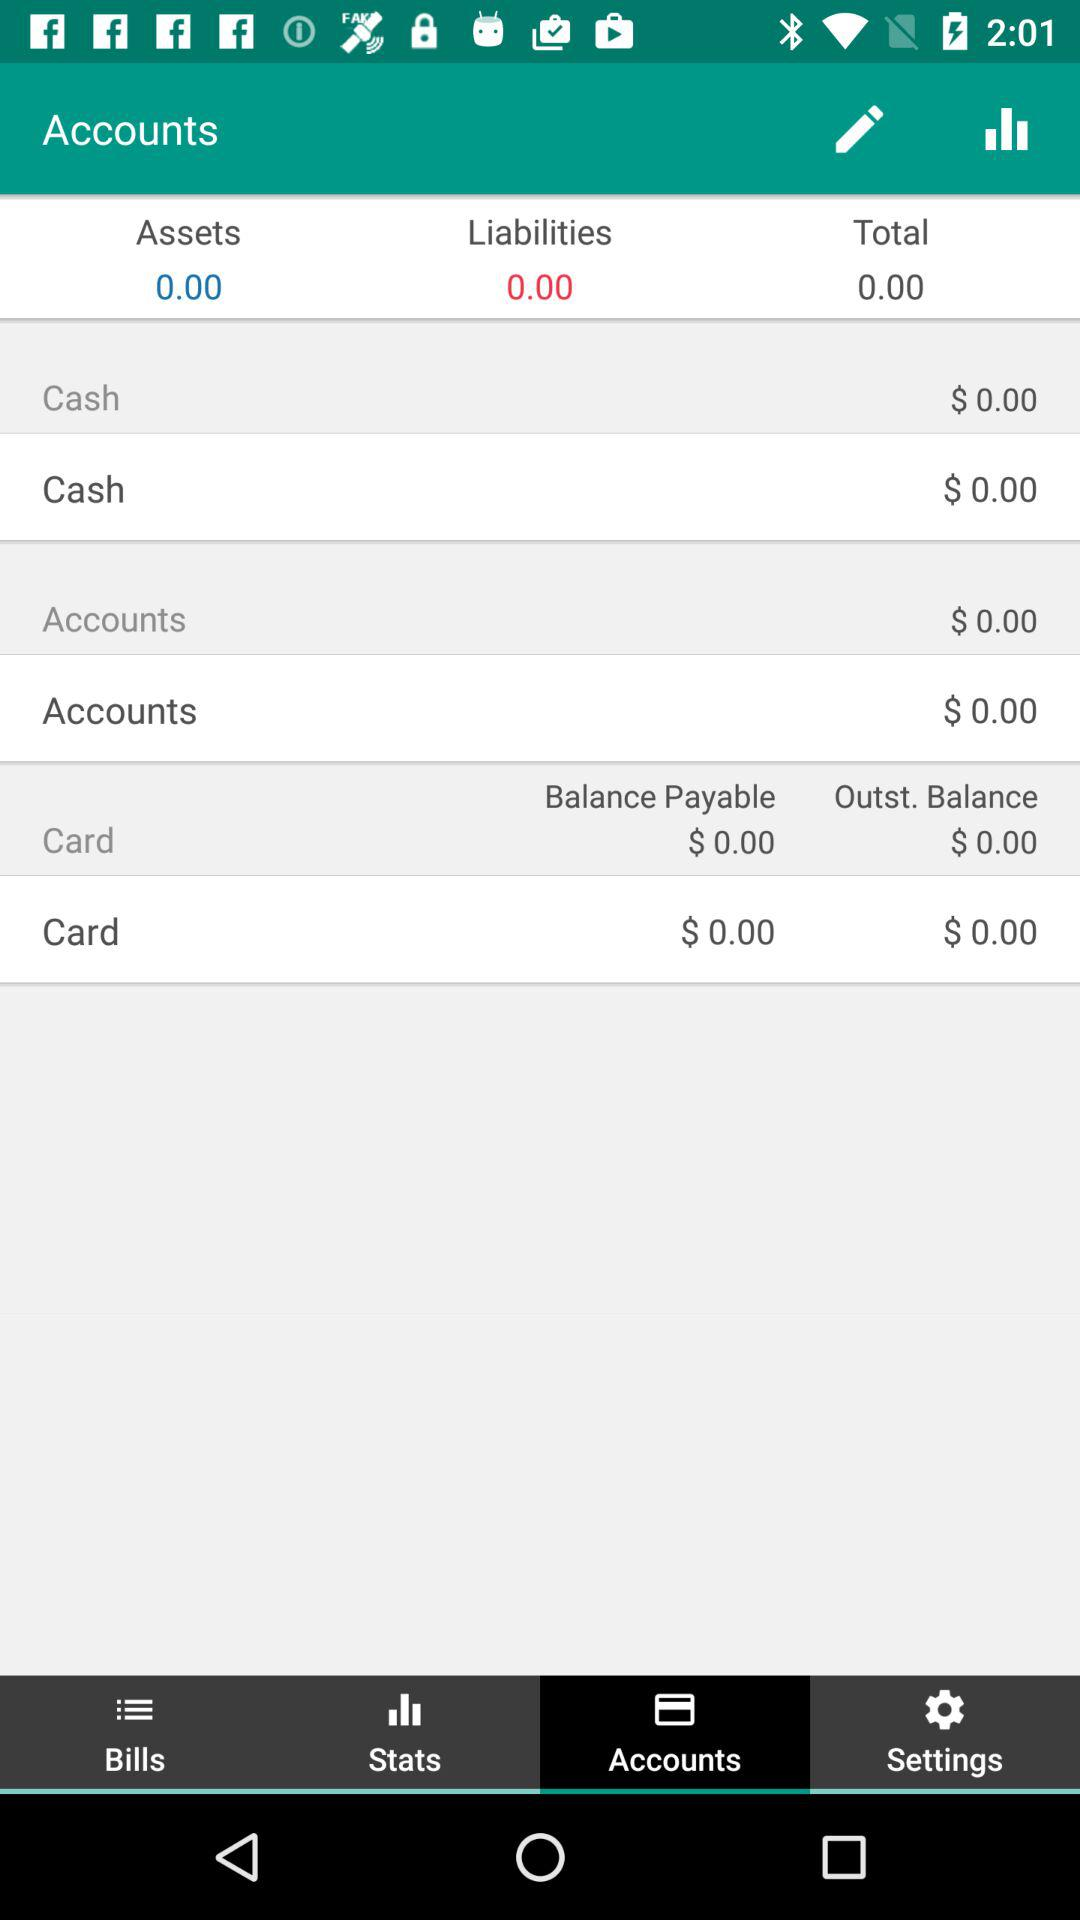What is the selected tab? The selected tab is "Accounts". 